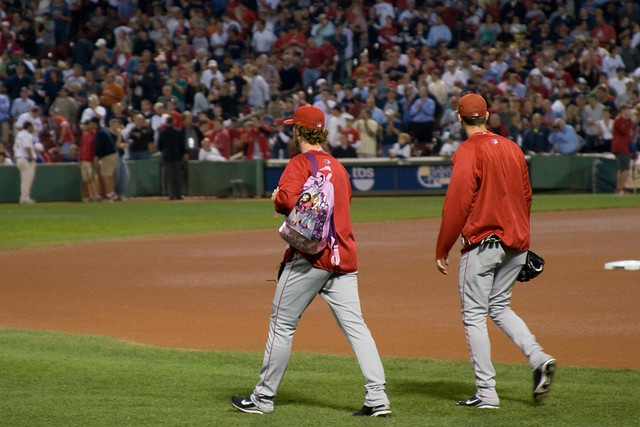Describe the objects in this image and their specific colors. I can see people in black, brown, darkgray, and maroon tones, people in black, darkgray, lightgray, and brown tones, people in black, gray, maroon, and darkgray tones, backpack in black, purple, darkgray, and maroon tones, and people in black, maroon, and gray tones in this image. 